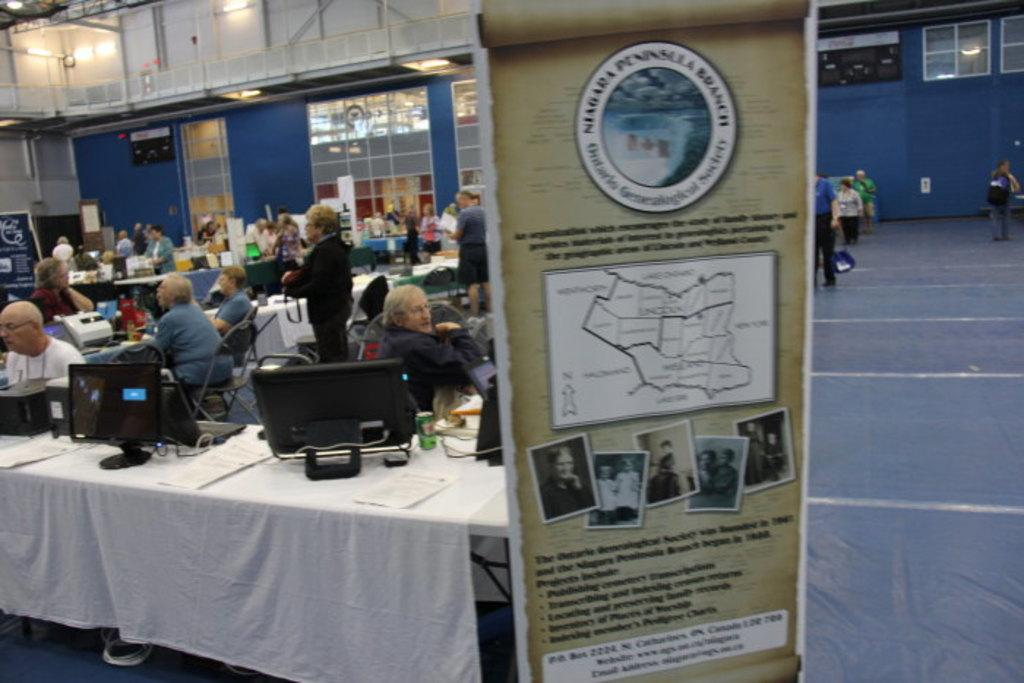<image>
Share a concise interpretation of the image provided. The location on the sign is the Niagara Peninsula Branch. 